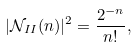<formula> <loc_0><loc_0><loc_500><loc_500>| \mathcal { N } _ { I I } ( n ) | ^ { 2 } = \frac { 2 ^ { - n } } { n ! } ,</formula> 